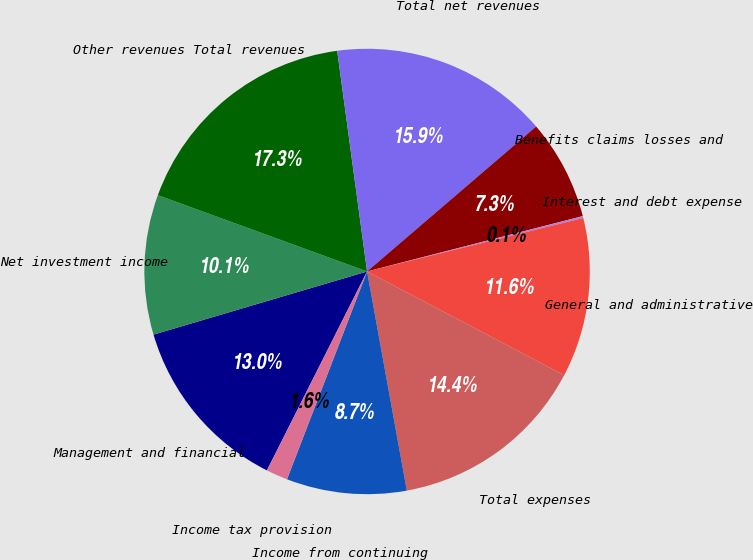<chart> <loc_0><loc_0><loc_500><loc_500><pie_chart><fcel>Management and financial<fcel>Net investment income<fcel>Other revenues Total revenues<fcel>Total net revenues<fcel>Benefits claims losses and<fcel>Interest and debt expense<fcel>General and administrative<fcel>Total expenses<fcel>Income from continuing<fcel>Income tax provision<nl><fcel>13.0%<fcel>10.14%<fcel>17.29%<fcel>15.86%<fcel>7.28%<fcel>0.14%<fcel>11.57%<fcel>14.43%<fcel>8.71%<fcel>1.57%<nl></chart> 